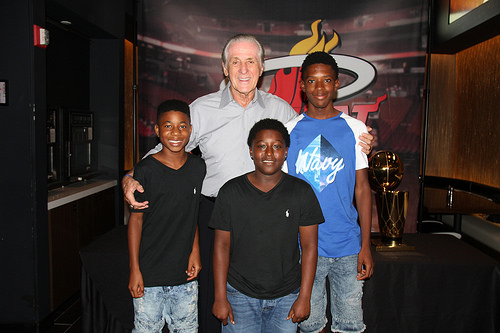<image>
Can you confirm if the black shirt is on the old guy? No. The black shirt is not positioned on the old guy. They may be near each other, but the black shirt is not supported by or resting on top of the old guy. Is the boy next to the old man? Yes. The boy is positioned adjacent to the old man, located nearby in the same general area. 